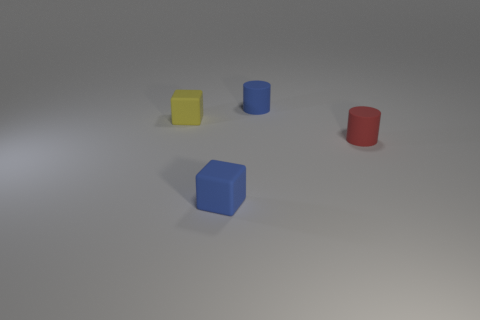Add 4 small green metallic things. How many objects exist? 8 Add 4 small rubber things. How many small rubber things are left? 8 Add 3 brown metal spheres. How many brown metal spheres exist? 3 Subtract 0 green balls. How many objects are left? 4 Subtract all yellow matte things. Subtract all red rubber objects. How many objects are left? 2 